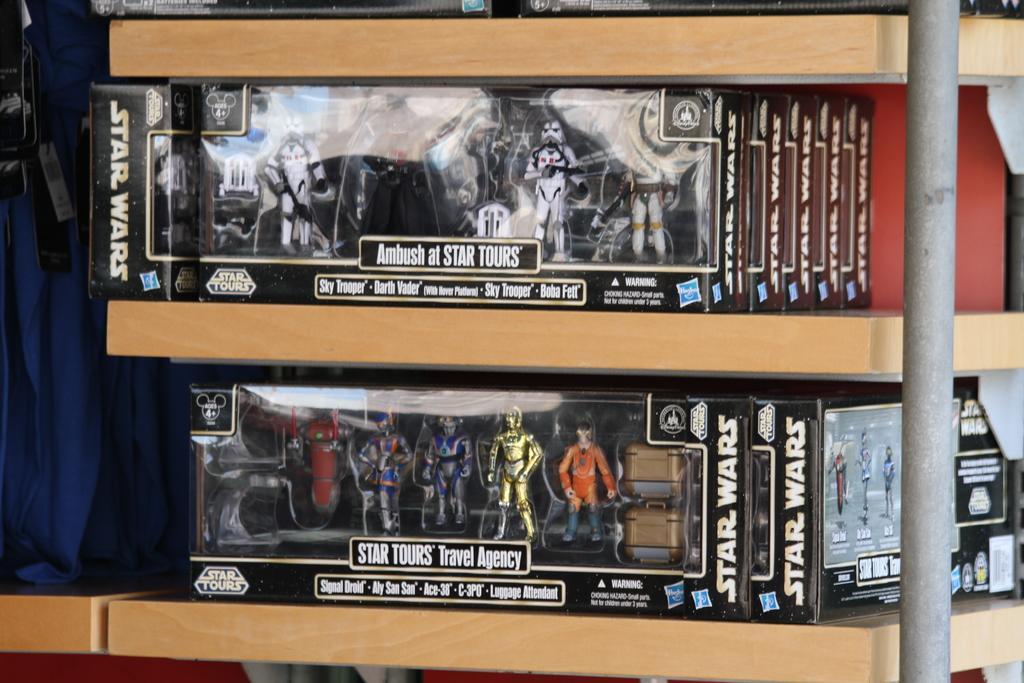Can you describe this image briefly? In this image we can see a group of dolls in the cardboard boxes which are placed in the racks. We can also see the tags on clothes. We can also see a pole. 